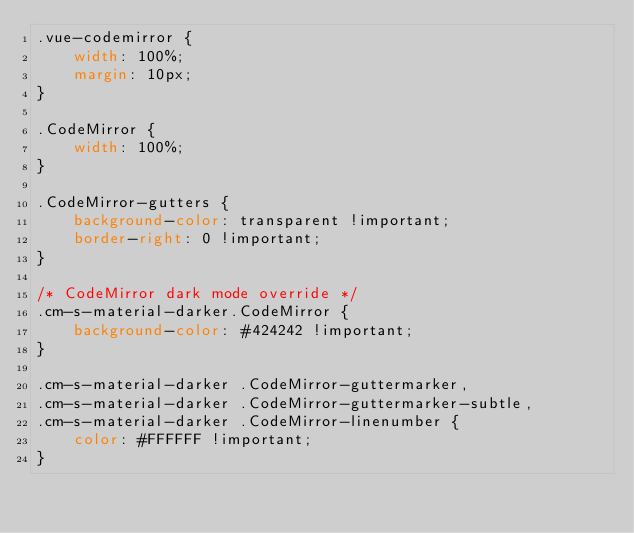Convert code to text. <code><loc_0><loc_0><loc_500><loc_500><_CSS_>.vue-codemirror {
    width: 100%;
    margin: 10px;
}

.CodeMirror {
    width: 100%;
}

.CodeMirror-gutters {
    background-color: transparent !important;
    border-right: 0 !important;
}

/* CodeMirror dark mode override */
.cm-s-material-darker.CodeMirror {
    background-color: #424242 !important;
}

.cm-s-material-darker .CodeMirror-guttermarker,
.cm-s-material-darker .CodeMirror-guttermarker-subtle,
.cm-s-material-darker .CodeMirror-linenumber {
    color: #FFFFFF !important;
}
</code> 